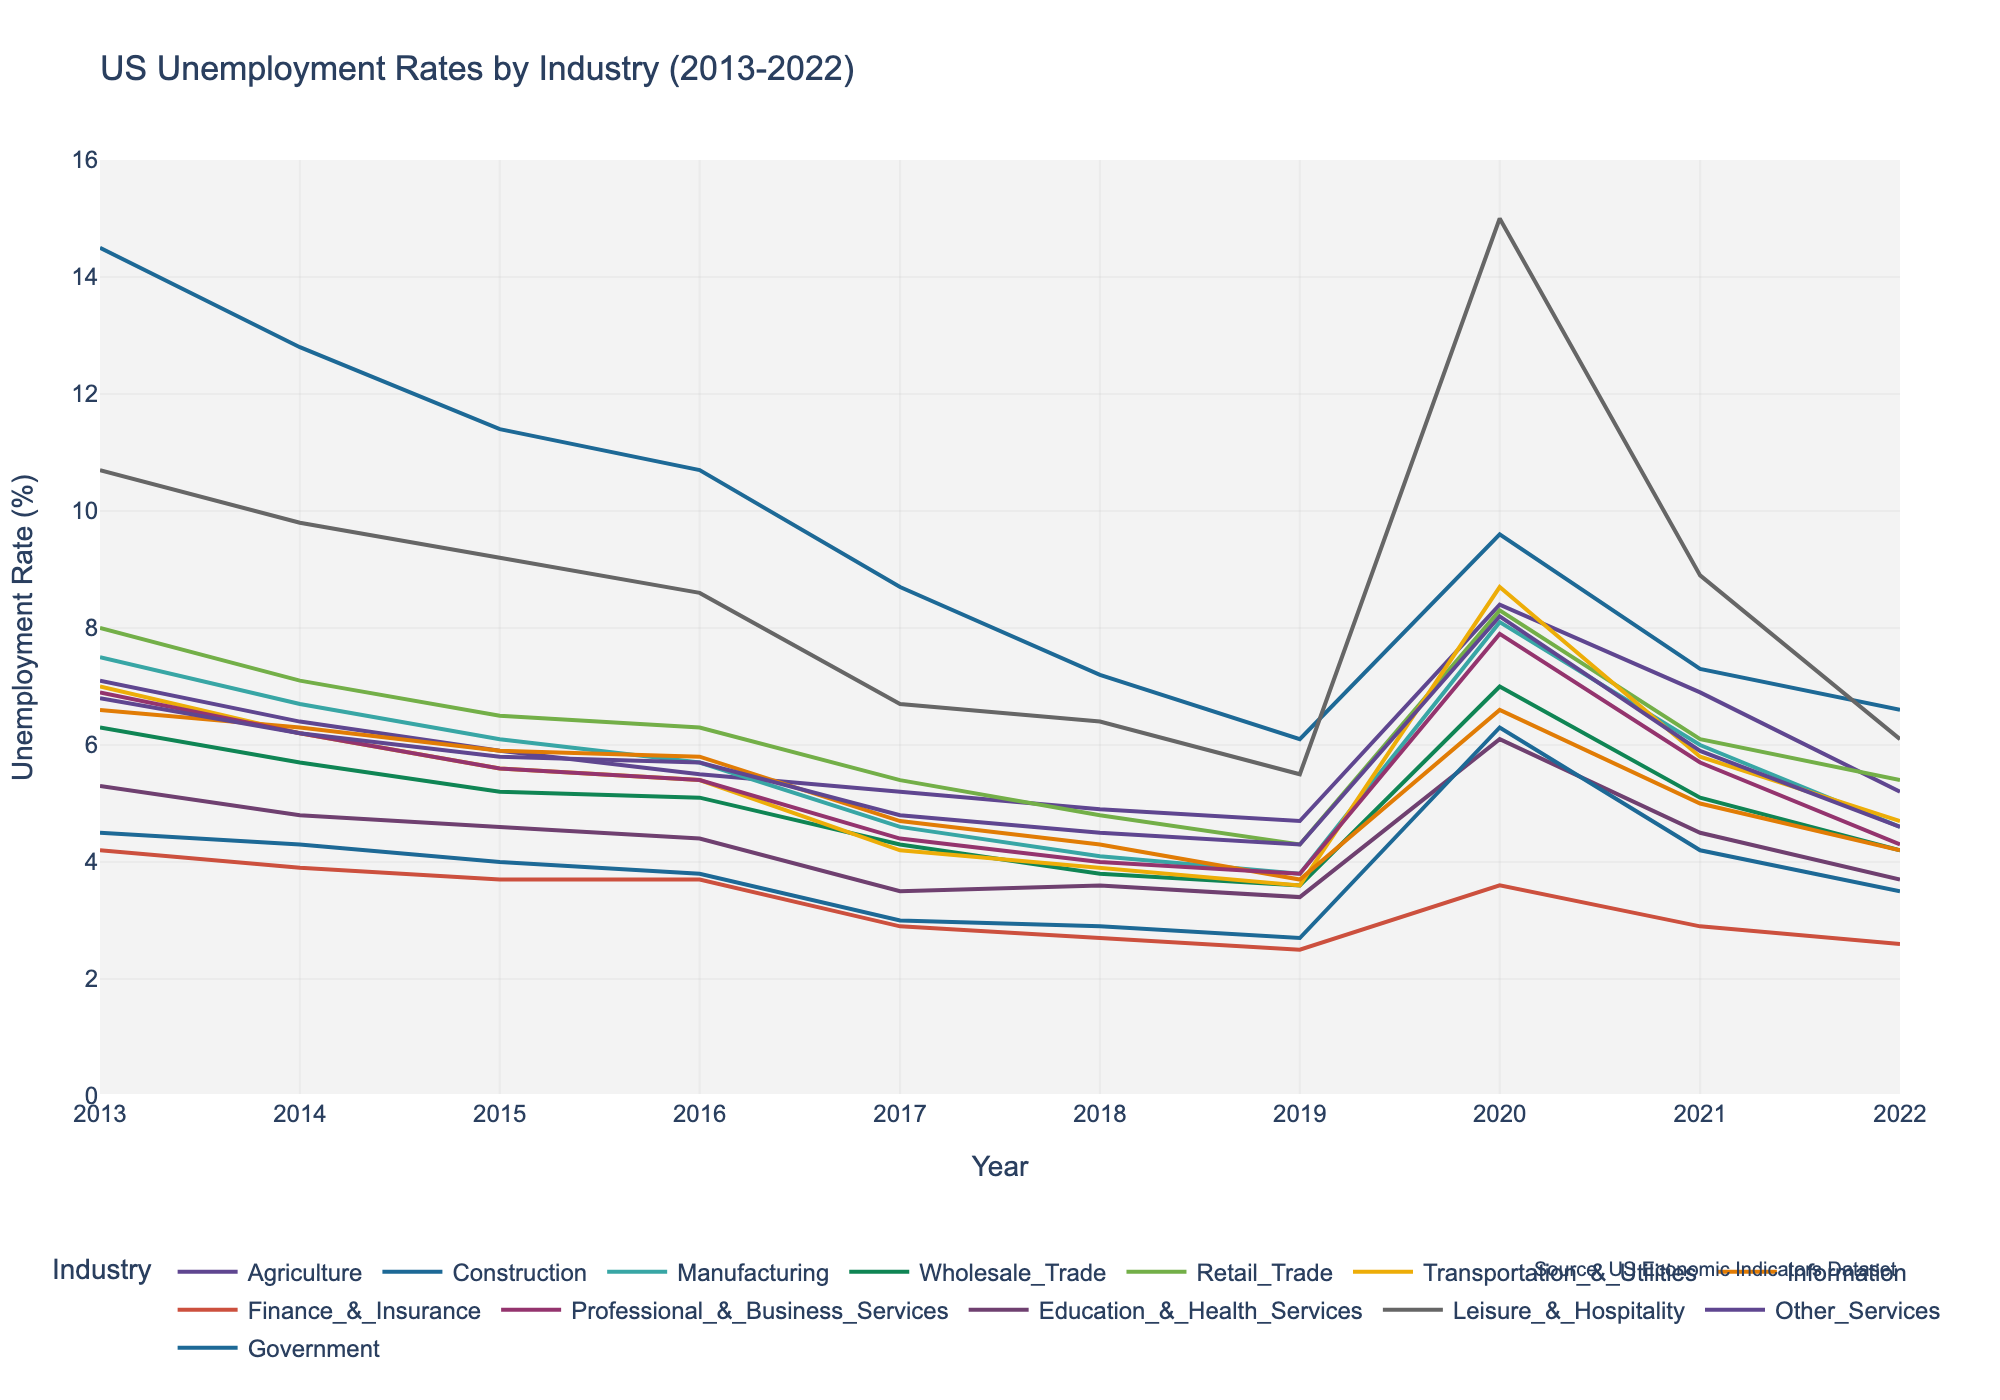What is the title of the plot? The plot's title appears prominently at the top of the figure and reads "US Unemployment Rates by Industry (2013-2022)"
Answer: US Unemployment Rates by Industry (2013-2022) How many industries are represented in the plot? Each industry's line is represented by a different color, with a corresponding label in the legend at the bottom of the plot. Counting these labels will give the number of industries.
Answer: 13 Which industry had the highest unemployment rate in 2020? Look at the lines for each industry in the year 2020 and identify the one that reaches the highest point on the y-axis. The Leisure & Hospitality line reaches the highest point in 2020.
Answer: Leisure & Hospitality What was the unemployment rate for the Government sector in 2017? Locate the line representing the Government sector in the legend, then find the data point corresponding to the year 2017 on this line.
Answer: 3.0% In which year did the Construction industry's unemployment rate drop below 10% for the first time within the given range? Follow the line for Construction from left to right, and identify the first year where the rate dips below the 10% mark on the y-axis.
Answer: 2017 On average, which industry had a lower unemployment rate: Agriculture or Information from 2013 to 2022? Calculate the average unemployment rate for each industry by summing their annual rates and dividing by the number of years (10). Compare these averages.
Answer: Information By what percent did the unemployment rate in the Retail Trade industry change from 2019 to 2020? Locate the Retail Trade data points in 2019 and 2020. Subtract the 2019 value from the 2020 value, then divide by the 2019 value and multiply by 100 to get the percentage change.
Answer: {(8.3 - 4.3)/4.3} * 100 = 93.02% Which industry showed a consistent decline in unemployment rate from 2015 to 2019? Trace each industry's line from 2015 to 2019 and identify the one that continuously slopes downward. The Finance & Insurance line shows a consistent decline during this period.
Answer: Finance & Insurance How many years saw the unemployment rate for Education & Health Services fall below 4%? Find and count the data points on the Education & Health Services line that fall below the 4% mark on the y-axis.
Answer: 3 (2017, 2019, 2022) 